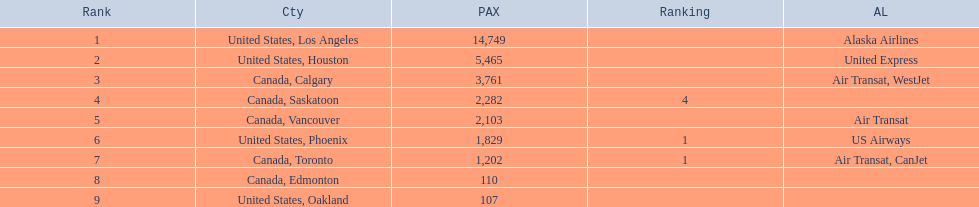What are all the cities? United States, Los Angeles, United States, Houston, Canada, Calgary, Canada, Saskatoon, Canada, Vancouver, United States, Phoenix, Canada, Toronto, Canada, Edmonton, United States, Oakland. How many passengers do they service? 14,749, 5,465, 3,761, 2,282, 2,103, 1,829, 1,202, 110, 107. Which city, when combined with los angeles, totals nearly 19,000? Canada, Calgary. 